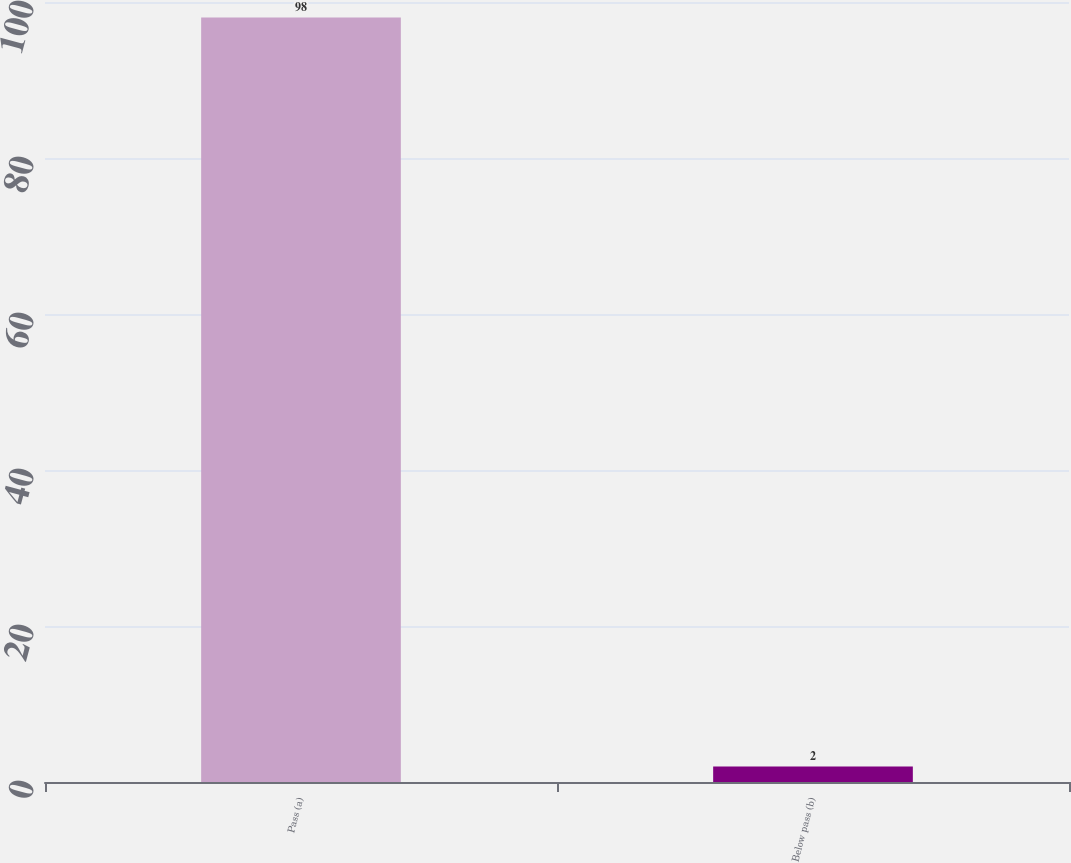<chart> <loc_0><loc_0><loc_500><loc_500><bar_chart><fcel>Pass (a)<fcel>Below pass (b)<nl><fcel>98<fcel>2<nl></chart> 